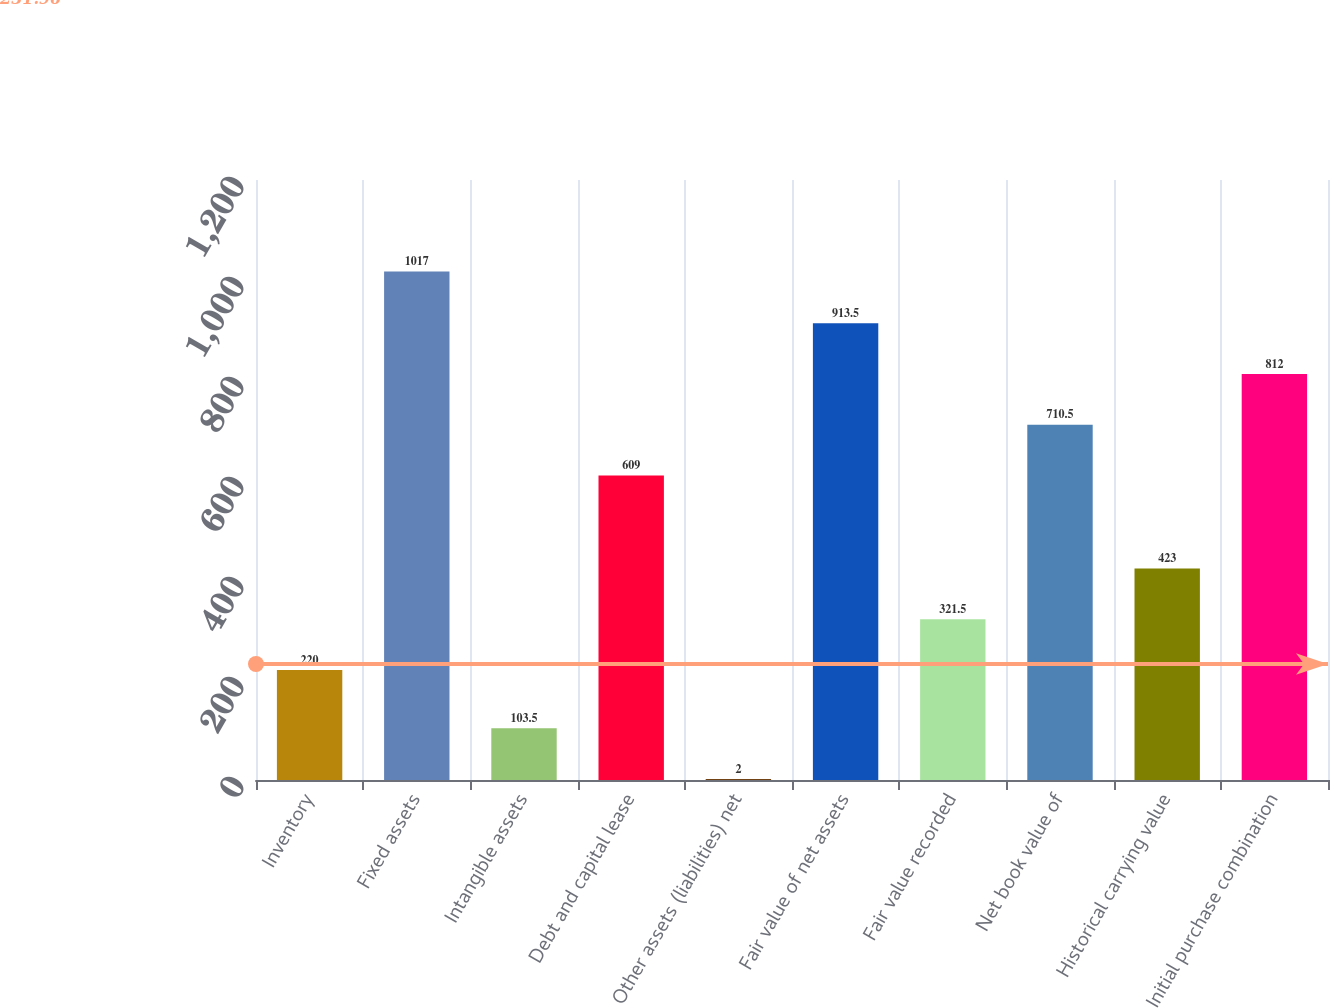Convert chart to OTSL. <chart><loc_0><loc_0><loc_500><loc_500><bar_chart><fcel>Inventory<fcel>Fixed assets<fcel>Intangible assets<fcel>Debt and capital lease<fcel>Other assets (liabilities) net<fcel>Fair value of net assets<fcel>Fair value recorded<fcel>Net book value of<fcel>Historical carrying value<fcel>Initial purchase combination<nl><fcel>220<fcel>1017<fcel>103.5<fcel>609<fcel>2<fcel>913.5<fcel>321.5<fcel>710.5<fcel>423<fcel>812<nl></chart> 